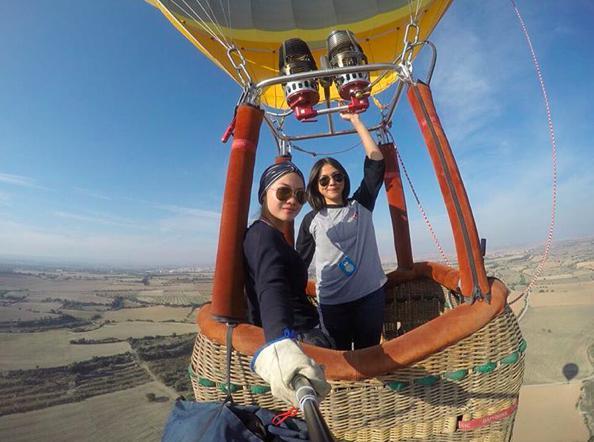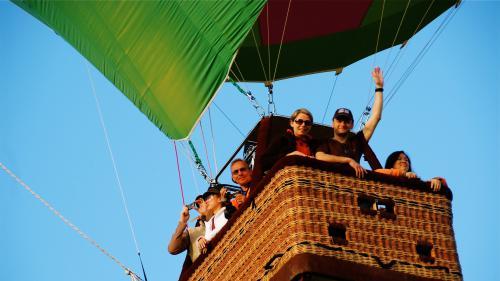The first image is the image on the left, the second image is the image on the right. Analyze the images presented: Is the assertion "Both images show people in hot air balloon baskets floating in midair." valid? Answer yes or no. Yes. 